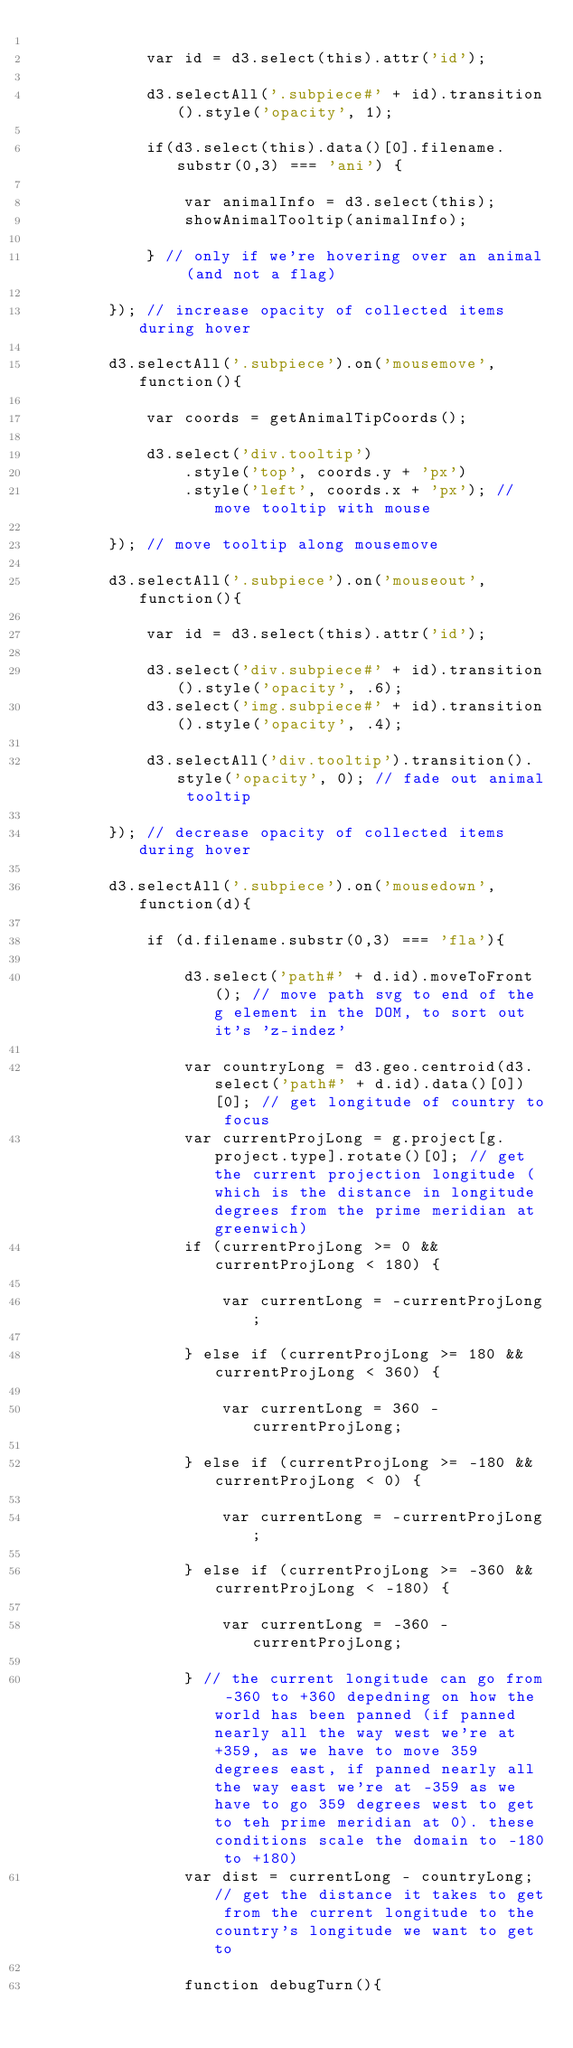Convert code to text. <code><loc_0><loc_0><loc_500><loc_500><_JavaScript_>
			var id = d3.select(this).attr('id');

			d3.selectAll('.subpiece#' + id).transition().style('opacity', 1);
			
			if(d3.select(this).data()[0].filename.substr(0,3) === 'ani') {

				var animalInfo = d3.select(this);
				showAnimalTooltip(animalInfo); 

			} // only if we're hovering over an animal (and not a flag)

		}); // increase opacity of collected items during hover 

		d3.selectAll('.subpiece').on('mousemove', function(){

			var coords = getAnimalTipCoords();

			d3.select('div.tooltip')
				.style('top', coords.y + 'px')
				.style('left', coords.x + 'px'); // move tooltip with mouse

		}); // move tooltip along mousemove

		d3.selectAll('.subpiece').on('mouseout', function(){

			var id = d3.select(this).attr('id');

			d3.select('div.subpiece#' + id).transition().style('opacity', .6);
			d3.select('img.subpiece#' + id).transition().style('opacity', .4);
			
			d3.selectAll('div.tooltip').transition().style('opacity', 0); // fade out animal tooltip

		}); // decrease opacity of collected items during hover 

		d3.selectAll('.subpiece').on('mousedown', function(d){

			if (d.filename.substr(0,3) === 'fla'){
				
				d3.select('path#' + d.id).moveToFront(); // move path svg to end of the g element in the DOM, to sort out it's 'z-indez'

				var countryLong = d3.geo.centroid(d3.select('path#' + d.id).data()[0])[0]; // get longitude of country to focus
				var currentProjLong = g.project[g.project.type].rotate()[0]; // get the current projection longitude (which is the distance in longitude degrees from the prime meridian at greenwich)
				if (currentProjLong >= 0 && currentProjLong < 180) {
					
					var currentLong = -currentProjLong;
					
				} else if (currentProjLong >= 180 && currentProjLong < 360) {

					var currentLong = 360 - currentProjLong;

				} else if (currentProjLong >= -180 && currentProjLong < 0) {

					var currentLong = -currentProjLong;

				} else if (currentProjLong >= -360 && currentProjLong < -180) {

					var currentLong = -360 - currentProjLong;

				} // the current longitude can go from -360 to +360 depedning on how the world has been panned (if panned nearly all the way west we're at +359, as we have to move 359 degrees east, if panned nearly all the way east we're at -359 as we have to go 359 degrees west to get to teh prime meridian at 0). these conditions scale the domain to -180 to +180)
				var dist = currentLong - countryLong; // get the distance it takes to get from the current longitude to the country's longitude we want to get to

				function debugTurn(){</code> 